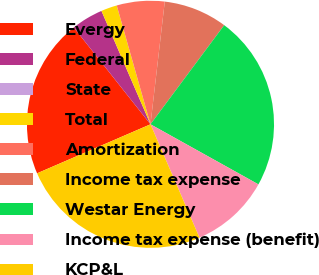Convert chart. <chart><loc_0><loc_0><loc_500><loc_500><pie_chart><fcel>Evergy<fcel>Federal<fcel>State<fcel>Total<fcel>Amortization<fcel>Income tax expense<fcel>Westar Energy<fcel>Income tax expense (benefit)<fcel>KCP&L<nl><fcel>20.83%<fcel>4.17%<fcel>0.0%<fcel>2.09%<fcel>6.25%<fcel>8.33%<fcel>22.91%<fcel>10.42%<fcel>25.0%<nl></chart> 